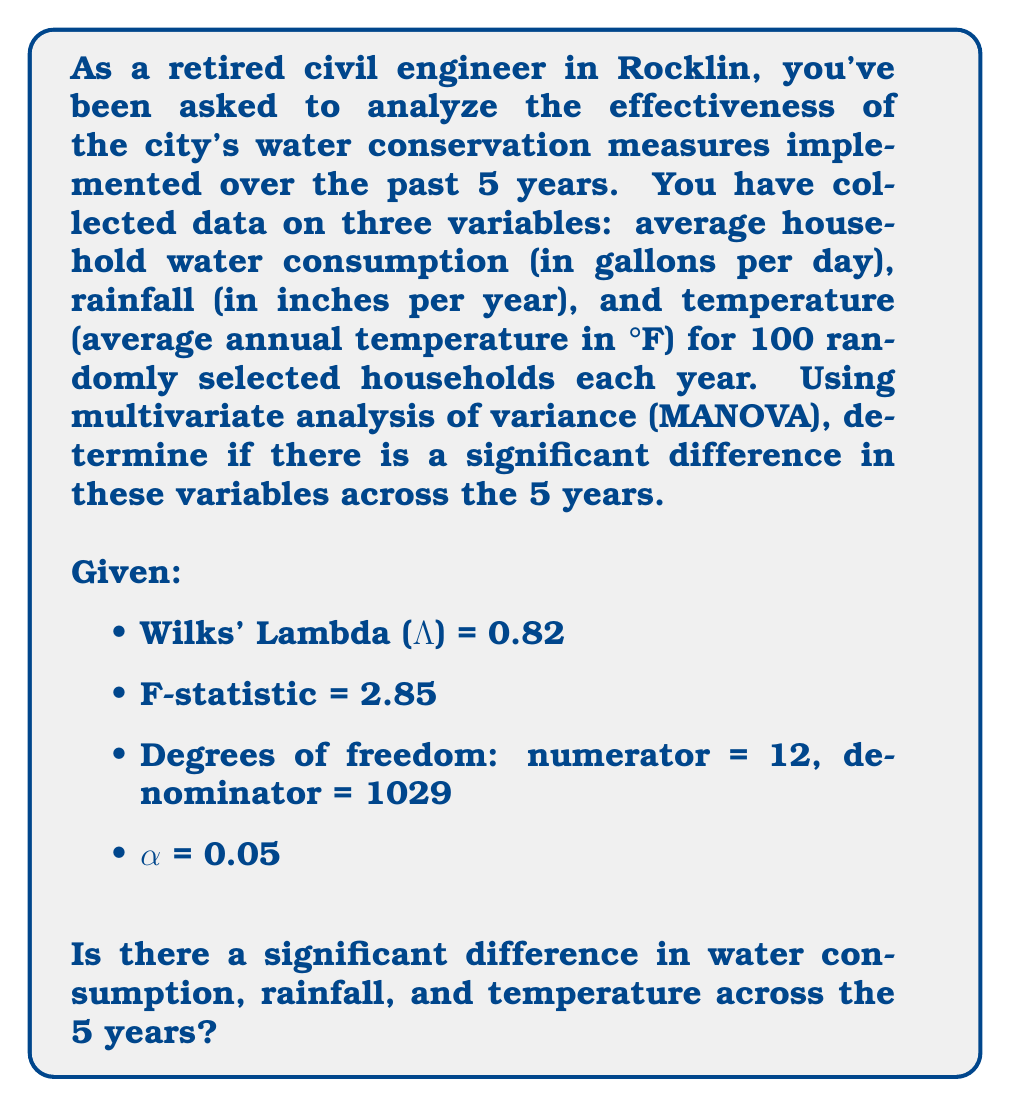Show me your answer to this math problem. To determine if there's a significant difference in water consumption, rainfall, and temperature across the 5 years using MANOVA, we'll follow these steps:

1. State the null and alternative hypotheses:
   $H_0$: There is no significant difference in the multivariate means across the 5 years.
   $H_a$: There is a significant difference in the multivariate means across the 5 years.

2. Identify the test statistic and its distribution:
   We're given Wilks' Lambda (Λ) = 0.82 and the F-statistic = 2.85.
   The F-statistic follows an F-distribution with degrees of freedom: numerator = 12, denominator = 1029.

3. Determine the critical F-value:
   Using an F-table or statistical software, we find the critical F-value for α = 0.05, df1 = 12, and df2 = 1029:
   $F_{critical} ≈ 1.75$

4. Compare the calculated F-statistic to the critical F-value:
   $F_{calculated} = 2.85 > F_{critical} = 1.75$

5. Make a decision:
   Since the calculated F-statistic is greater than the critical F-value, we reject the null hypothesis.

6. Interpret the result:
   Rejecting the null hypothesis means there is statistically significant evidence to suggest that there are differences in the multivariate means (water consumption, rainfall, and temperature) across the 5 years.

7. Calculate the effect size using Wilks' Lambda:
   Effect size = $1 - \Lambda^{1/s}$, where s = min(p, df_effect), p is the number of dependent variables.
   $s = \min(3, 4) = 3$
   Effect size = $1 - 0.82^{1/3} ≈ 0.0645$

This effect size indicates a small to moderate practical significance of the differences found across the 5 years.
Answer: Significant difference exists (p < 0.05, small to moderate effect size). 